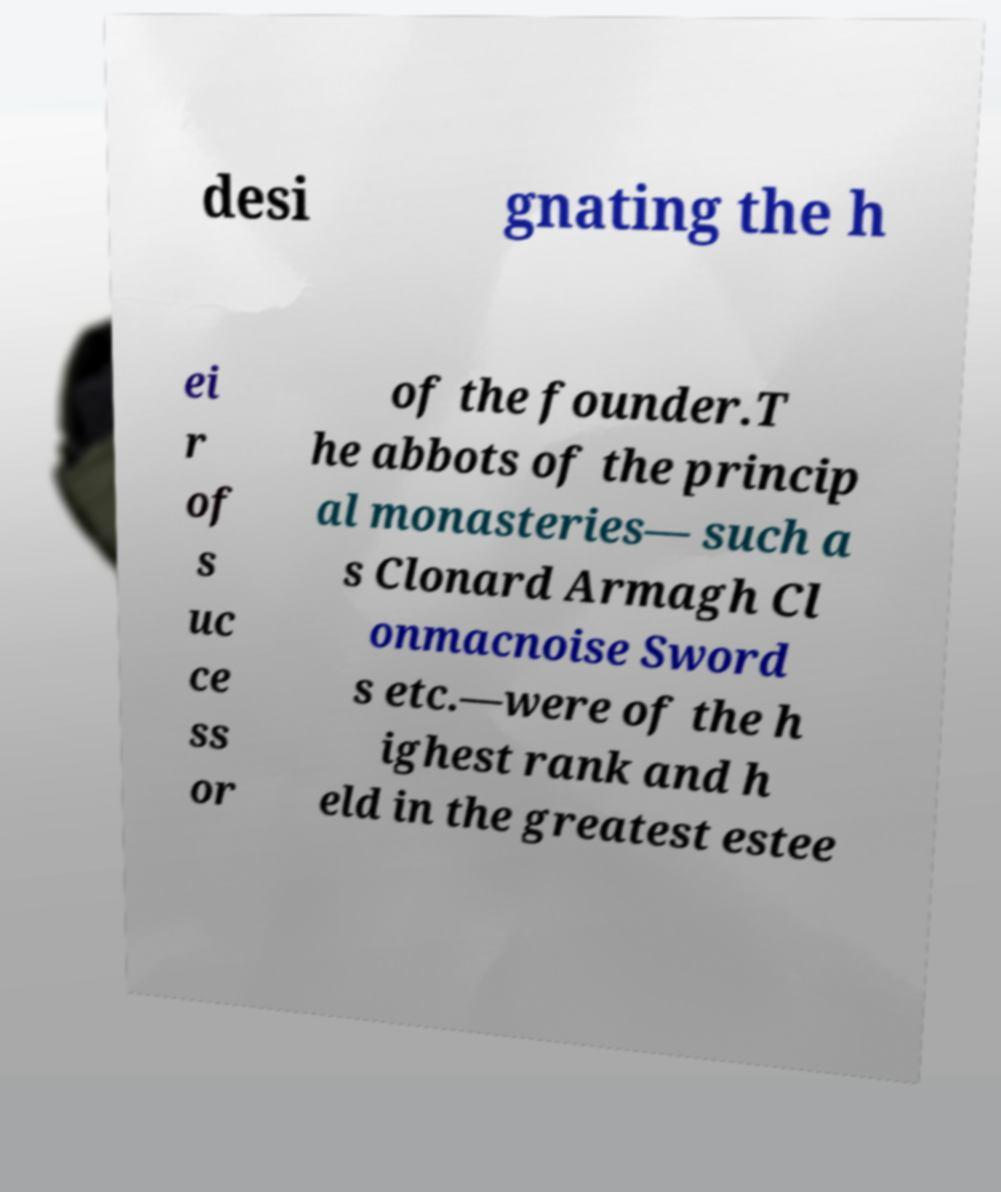Could you extract and type out the text from this image? desi gnating the h ei r of s uc ce ss or of the founder.T he abbots of the princip al monasteries— such a s Clonard Armagh Cl onmacnoise Sword s etc.—were of the h ighest rank and h eld in the greatest estee 